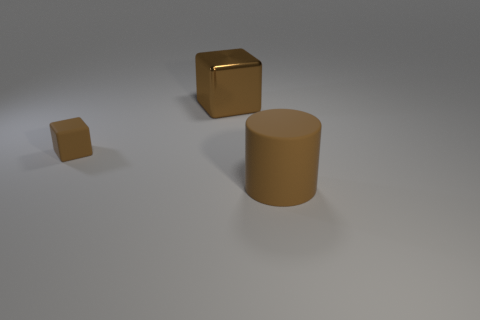Add 1 big brown blocks. How many objects exist? 4 Subtract 1 cubes. How many cubes are left? 1 Subtract all cylinders. How many objects are left? 2 Subtract 1 brown cylinders. How many objects are left? 2 Subtract all green cubes. Subtract all brown cylinders. How many cubes are left? 2 Subtract all tiny brown matte objects. Subtract all small cyan matte objects. How many objects are left? 2 Add 1 tiny brown matte things. How many tiny brown matte things are left? 2 Add 3 large green objects. How many large green objects exist? 3 